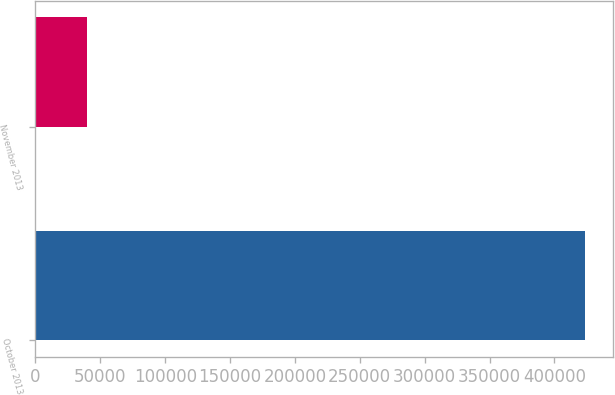Convert chart. <chart><loc_0><loc_0><loc_500><loc_500><bar_chart><fcel>October 2013<fcel>November 2013<nl><fcel>423800<fcel>40000<nl></chart> 